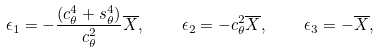Convert formula to latex. <formula><loc_0><loc_0><loc_500><loc_500>\epsilon _ { 1 } = - \frac { ( c _ { \theta } ^ { 4 } + s _ { \theta } ^ { 4 } ) } { c _ { \theta } ^ { 2 } } \overline { X } , \quad \epsilon _ { 2 } = - c _ { \theta } ^ { 2 } \overline { X } , \quad \epsilon _ { 3 } = - \overline { X } ,</formula> 